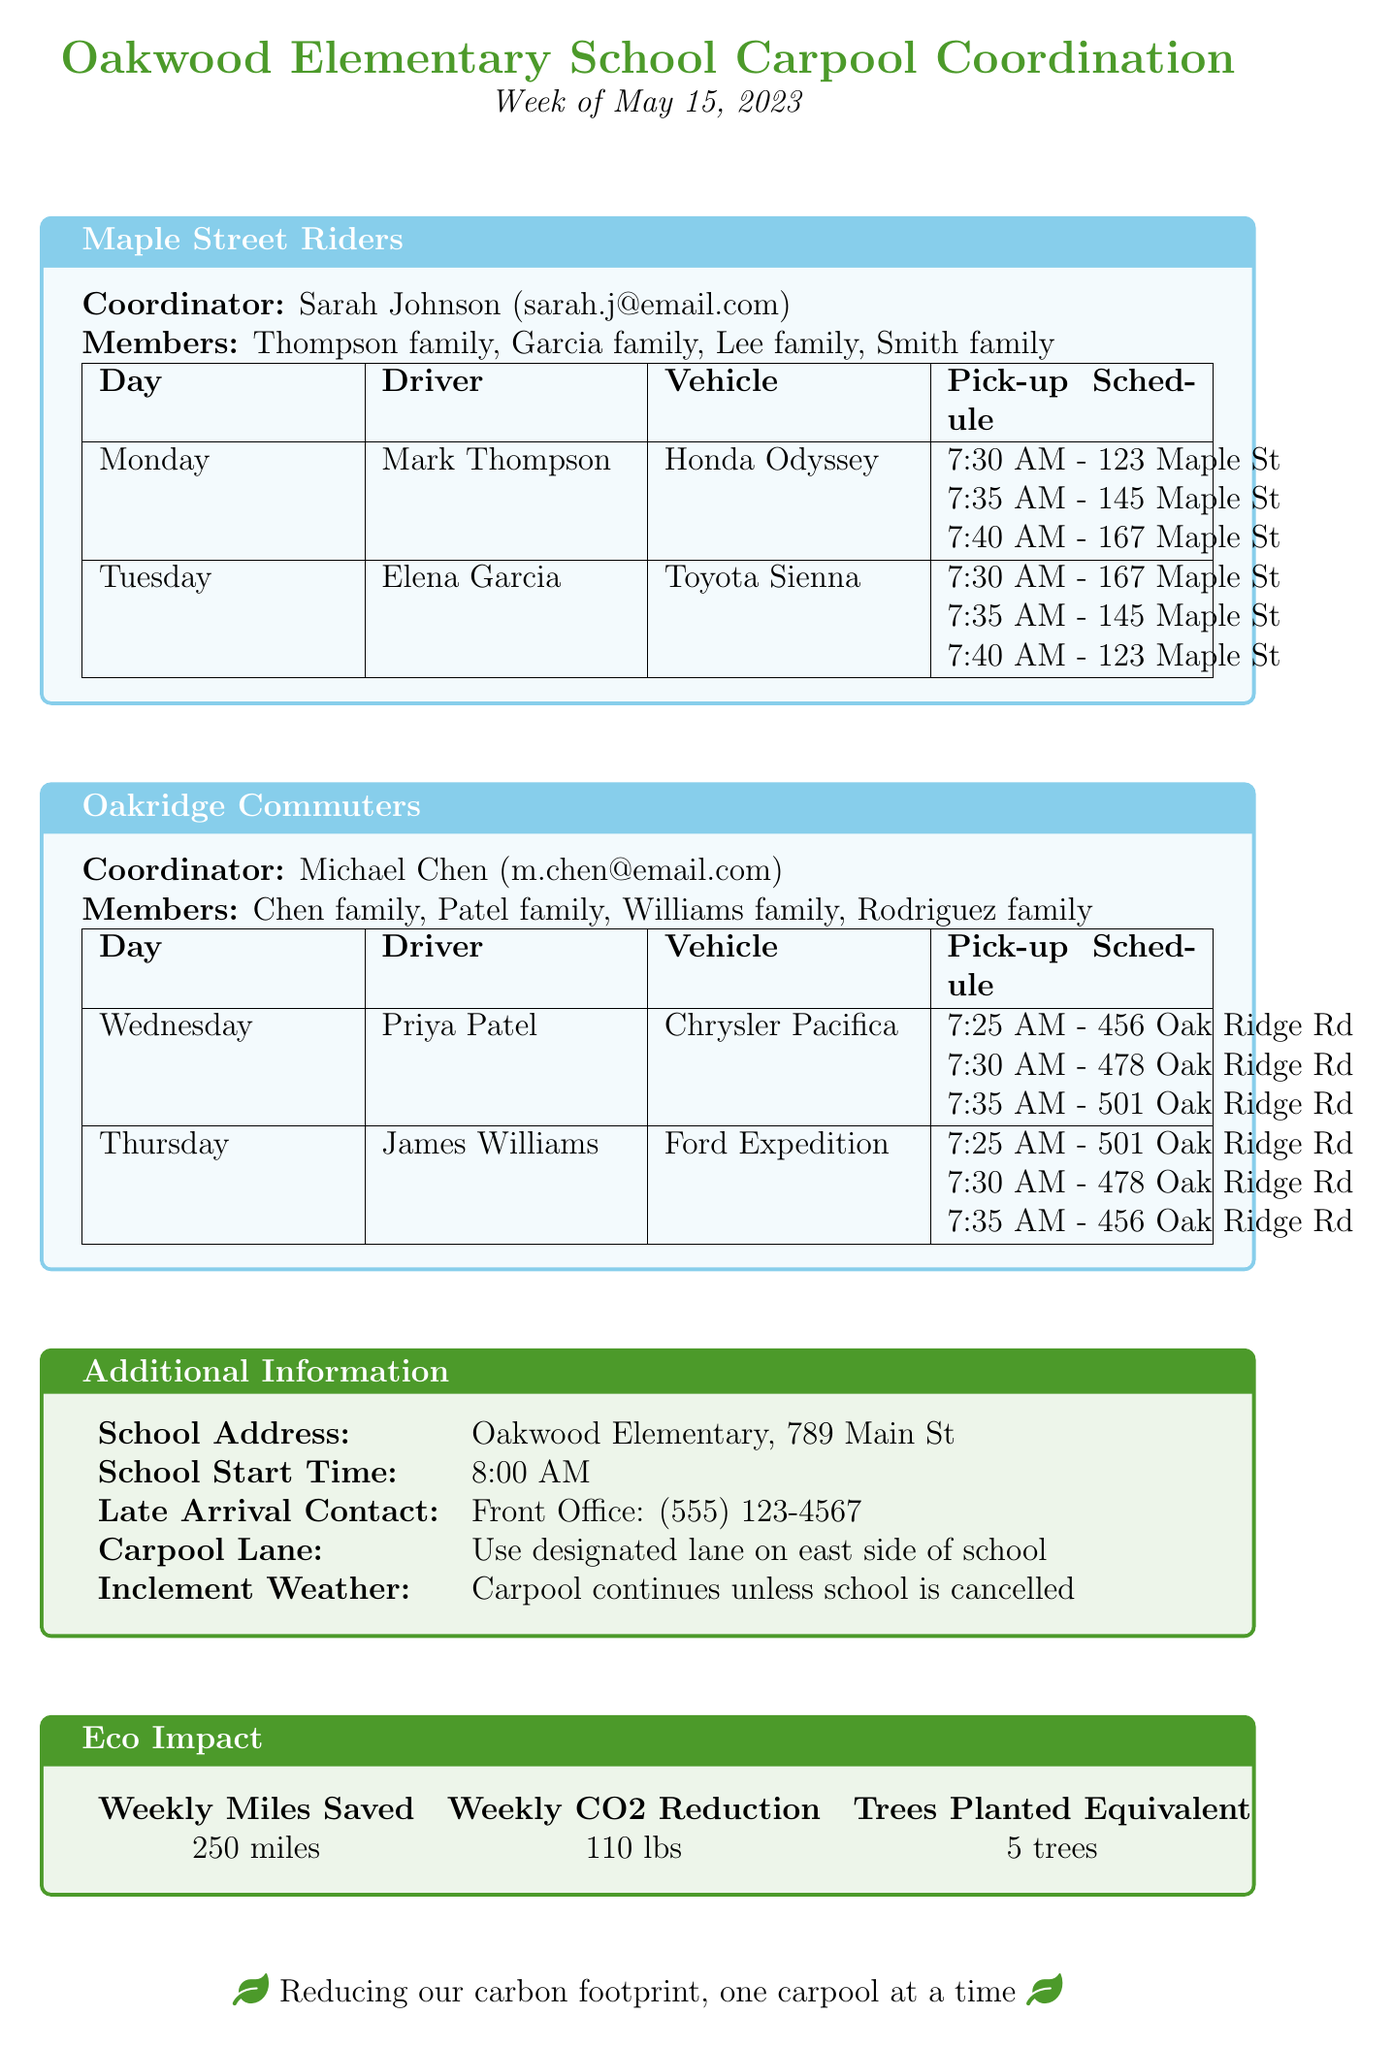What is the name of the coordinator for Maple Street Riders? The coordinator is listed under the "Maple Street Riders" section in the schedule.
Answer: Sarah Johnson What vehicle does Mark Thompson drive? The driver and vehicle are detailed in the schedule for the group he is part of.
Answer: Honda Odyssey What day does Priya Patel drive? The specific day each driver operates is clearly listed in their respective schedule.
Answer: Wednesday What is the estimated weekly miles saved? The eco impact section provides an estimation of weekly miles saved due to carpooling efforts.
Answer: 250 miles When is the Carpool Appreciation Day? The upcoming events section includes dates and descriptions for future events related to the carpool initiative.
Answer: May 19, 2023 How many families are part of the Oakridge Commuters group? The number of families is stated in the members list of the group.
Answer: Four families What is the pick-up time for 123 Maple St on Monday? The schedule provides specific pick-up times linked to each stop for the drivers.
Answer: 7:30 AM What is the inclement weather policy? The additional information section outlines the policy in place for inclement weather conditions.
Answer: Carpool continues unless school is cancelled What is the school's address? The school's address is provided under the additional information section for easy identification.
Answer: Oakwood Elementary, 789 Main St 